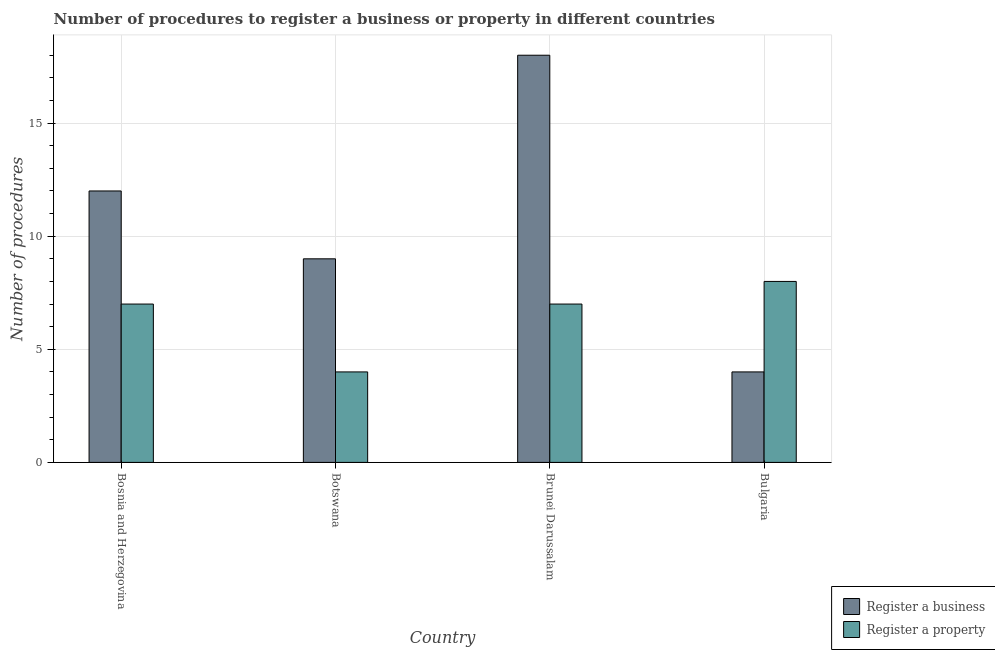How many bars are there on the 1st tick from the left?
Your answer should be very brief. 2. What is the label of the 3rd group of bars from the left?
Ensure brevity in your answer.  Brunei Darussalam. Across all countries, what is the maximum number of procedures to register a business?
Provide a short and direct response. 18. In which country was the number of procedures to register a business maximum?
Provide a succinct answer. Brunei Darussalam. In which country was the number of procedures to register a business minimum?
Your answer should be compact. Bulgaria. What is the average number of procedures to register a property per country?
Offer a very short reply. 6.5. What is the difference between the number of procedures to register a business and number of procedures to register a property in Botswana?
Provide a succinct answer. 5. Is the difference between the number of procedures to register a property in Bosnia and Herzegovina and Brunei Darussalam greater than the difference between the number of procedures to register a business in Bosnia and Herzegovina and Brunei Darussalam?
Ensure brevity in your answer.  Yes. What is the difference between the highest and the second highest number of procedures to register a property?
Your response must be concise. 1. What is the difference between the highest and the lowest number of procedures to register a property?
Keep it short and to the point. 4. Is the sum of the number of procedures to register a business in Botswana and Bulgaria greater than the maximum number of procedures to register a property across all countries?
Your answer should be compact. Yes. What does the 1st bar from the left in Botswana represents?
Give a very brief answer. Register a business. What does the 1st bar from the right in Bosnia and Herzegovina represents?
Give a very brief answer. Register a property. How many bars are there?
Offer a terse response. 8. How many countries are there in the graph?
Keep it short and to the point. 4. What is the difference between two consecutive major ticks on the Y-axis?
Provide a short and direct response. 5. Does the graph contain grids?
Your response must be concise. Yes. Where does the legend appear in the graph?
Offer a terse response. Bottom right. How many legend labels are there?
Offer a very short reply. 2. How are the legend labels stacked?
Keep it short and to the point. Vertical. What is the title of the graph?
Your response must be concise. Number of procedures to register a business or property in different countries. Does "Private credit bureau" appear as one of the legend labels in the graph?
Your response must be concise. No. What is the label or title of the Y-axis?
Give a very brief answer. Number of procedures. What is the Number of procedures of Register a property in Bosnia and Herzegovina?
Keep it short and to the point. 7. What is the Number of procedures in Register a business in Botswana?
Give a very brief answer. 9. What is the Number of procedures of Register a business in Brunei Darussalam?
Provide a short and direct response. 18. What is the Number of procedures of Register a business in Bulgaria?
Give a very brief answer. 4. What is the total Number of procedures of Register a property in the graph?
Your answer should be compact. 26. What is the difference between the Number of procedures of Register a business in Bosnia and Herzegovina and that in Botswana?
Ensure brevity in your answer.  3. What is the difference between the Number of procedures in Register a property in Bosnia and Herzegovina and that in Botswana?
Offer a terse response. 3. What is the difference between the Number of procedures in Register a property in Bosnia and Herzegovina and that in Brunei Darussalam?
Give a very brief answer. 0. What is the difference between the Number of procedures of Register a property in Botswana and that in Bulgaria?
Keep it short and to the point. -4. What is the difference between the Number of procedures of Register a business in Bosnia and Herzegovina and the Number of procedures of Register a property in Brunei Darussalam?
Offer a very short reply. 5. What is the difference between the Number of procedures in Register a business in Brunei Darussalam and the Number of procedures in Register a property in Bulgaria?
Your answer should be very brief. 10. What is the average Number of procedures in Register a business per country?
Your answer should be compact. 10.75. What is the average Number of procedures in Register a property per country?
Give a very brief answer. 6.5. What is the difference between the Number of procedures in Register a business and Number of procedures in Register a property in Bosnia and Herzegovina?
Your answer should be compact. 5. What is the difference between the Number of procedures in Register a business and Number of procedures in Register a property in Botswana?
Offer a terse response. 5. What is the difference between the Number of procedures of Register a business and Number of procedures of Register a property in Bulgaria?
Keep it short and to the point. -4. What is the ratio of the Number of procedures in Register a business in Bosnia and Herzegovina to that in Botswana?
Your response must be concise. 1.33. What is the ratio of the Number of procedures in Register a business in Bosnia and Herzegovina to that in Brunei Darussalam?
Give a very brief answer. 0.67. What is the ratio of the Number of procedures in Register a property in Bosnia and Herzegovina to that in Brunei Darussalam?
Give a very brief answer. 1. What is the ratio of the Number of procedures in Register a business in Bosnia and Herzegovina to that in Bulgaria?
Provide a short and direct response. 3. What is the ratio of the Number of procedures of Register a property in Bosnia and Herzegovina to that in Bulgaria?
Offer a very short reply. 0.88. What is the ratio of the Number of procedures of Register a business in Botswana to that in Brunei Darussalam?
Keep it short and to the point. 0.5. What is the ratio of the Number of procedures in Register a property in Botswana to that in Brunei Darussalam?
Keep it short and to the point. 0.57. What is the ratio of the Number of procedures in Register a business in Botswana to that in Bulgaria?
Ensure brevity in your answer.  2.25. What is the ratio of the Number of procedures in Register a property in Botswana to that in Bulgaria?
Offer a very short reply. 0.5. What is the ratio of the Number of procedures of Register a property in Brunei Darussalam to that in Bulgaria?
Your answer should be compact. 0.88. What is the difference between the highest and the second highest Number of procedures in Register a business?
Provide a short and direct response. 6. What is the difference between the highest and the second highest Number of procedures of Register a property?
Provide a short and direct response. 1. What is the difference between the highest and the lowest Number of procedures in Register a business?
Make the answer very short. 14. What is the difference between the highest and the lowest Number of procedures in Register a property?
Provide a short and direct response. 4. 